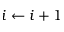<formula> <loc_0><loc_0><loc_500><loc_500>i \gets i + 1</formula> 